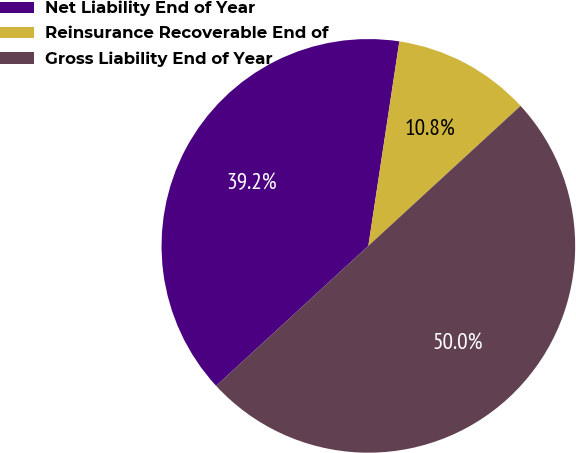Convert chart. <chart><loc_0><loc_0><loc_500><loc_500><pie_chart><fcel>Net Liability End of Year<fcel>Reinsurance Recoverable End of<fcel>Gross Liability End of Year<nl><fcel>39.23%<fcel>10.77%<fcel>50.0%<nl></chart> 